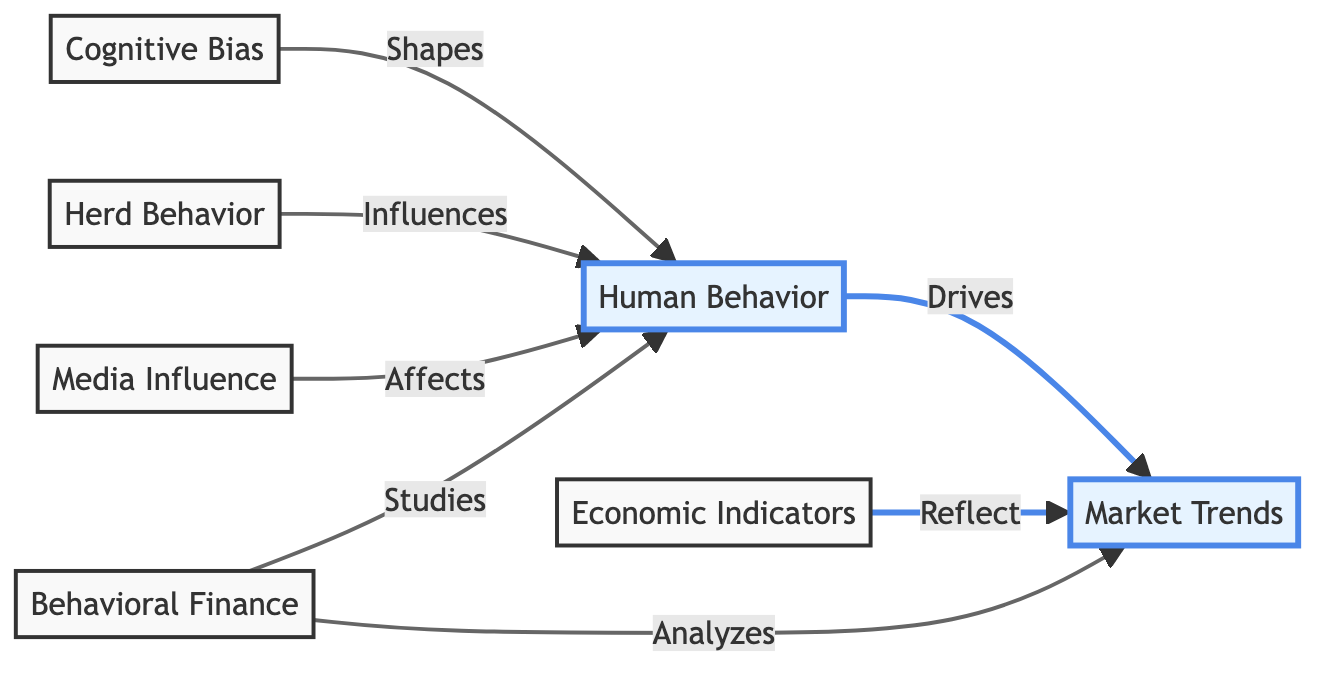What are the two main components depicted in the diagram? The diagram shows two main components: Human Behavior and Market Trends. These are represented as the two emphasis nodes at the top of the flowchart.
Answer: Human Behavior, Market Trends How many influence arrows are directed towards Human Behavior? The diagram indicates that there are three arrows influencing Human Behavior: from Cognitive Bias, Herd Behavior, and Media Influence. Counting these arrows reveals their number.
Answer: Three What does Behavioral Finance study? According to the diagram, Behavioral Finance studies Human Behavior, as indicated by the direct connection labeled "Studies."
Answer: Human Behavior What is the relationship between Economic Indicators and Market Trends? The diagram shows that Economic Indicators reflect Market Trends, represented by a direct arrow pointing from Economic Indicators to Market Trends labeled "Reflect."
Answer: Reflect How does Herd Behavior affect Human Behavior according to the diagram? The diagram reveals that Herd Behavior influences Human Behavior, as shown by the arrow labeled "Influences" directed from Herd Behavior to Human Behavior.
Answer: Influences What are the two forms of analysis conducted by Behavioral Finance? Behavioral Finance analyzes both Human Behavior and Market Trends, as indicated by the two arrows pointing to these nodes labeled "Analyzes."
Answer: Human Behavior, Market Trends How many total nodes are in the diagram? By counting all of the unique nodes in the diagram, we find there are a total of six nodes: Human Behavior, Market Trends, Cognitive Bias, Herd Behavior, Economic Indicators, and Media Influence.
Answer: Six What type of relationship do Cognitive Bias and Human Behavior have? The diagram indicates that Cognitive Bias shapes Human Behavior, depicted by the labeled arrow connecting the two nodes.
Answer: Shapes Which node is connected to both arrows from Behavioral Finance? The node connected to both arrows from Behavioral Finance is Human Behavior, as it has one arrow showing "Studies" and another showing "Analyzes."
Answer: Human Behavior 